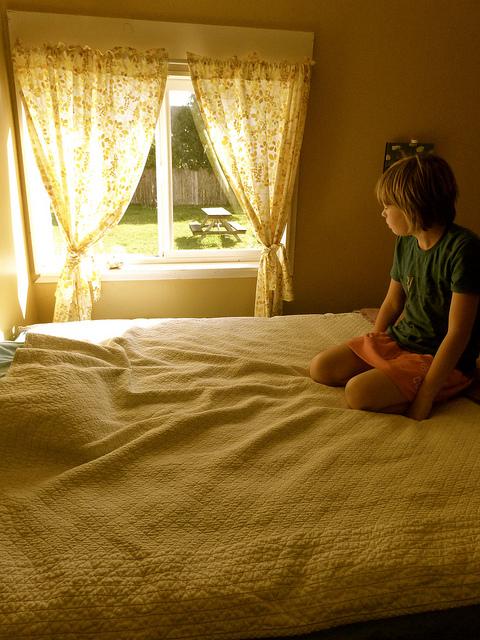What is in the backyard?
Keep it brief. Picnic table. What type of fence is in the yard?
Answer briefly. Wooden. Could she be in "time-out"?
Short answer required. Yes. 